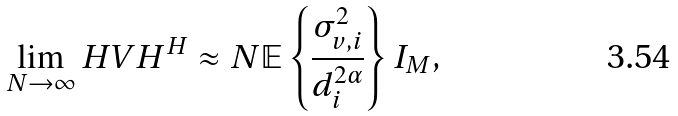Convert formula to latex. <formula><loc_0><loc_0><loc_500><loc_500>\lim _ { N \to \infty } H V H ^ { H } \approx N \mathbb { E } \left \{ \frac { \sigma _ { v , i } ^ { 2 } } { d _ { i } ^ { 2 \alpha } } \right \} I _ { M } ,</formula> 